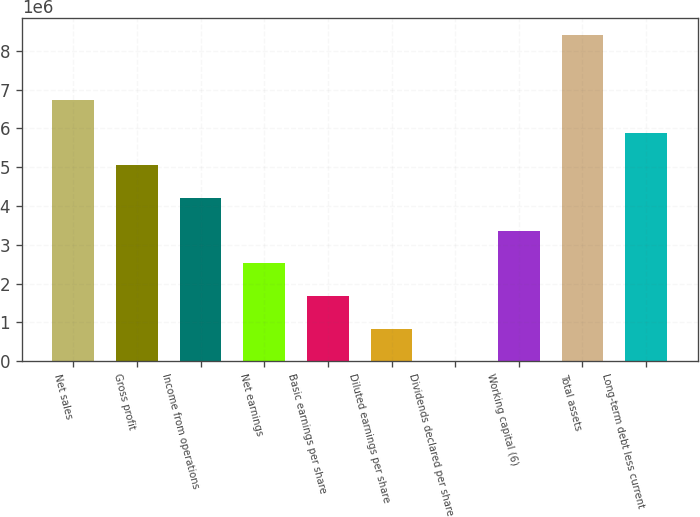Convert chart to OTSL. <chart><loc_0><loc_0><loc_500><loc_500><bar_chart><fcel>Net sales<fcel>Gross profit<fcel>Income from operations<fcel>Net earnings<fcel>Basic earnings per share<fcel>Diluted earnings per share<fcel>Dividends declared per share<fcel>Working capital (6)<fcel>Total assets<fcel>Long-term debt less current<nl><fcel>6.73035e+06<fcel>5.04776e+06<fcel>4.20647e+06<fcel>2.52388e+06<fcel>1.68259e+06<fcel>841294<fcel>0.85<fcel>3.36517e+06<fcel>8.41293e+06<fcel>5.88905e+06<nl></chart> 